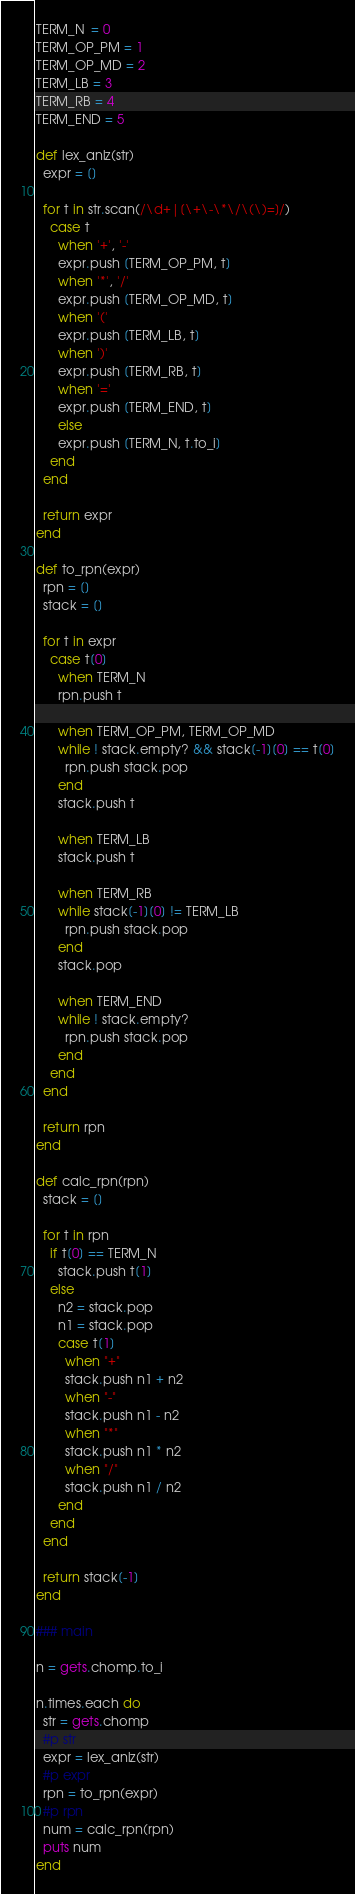<code> <loc_0><loc_0><loc_500><loc_500><_Ruby_>TERM_N  = 0
TERM_OP_PM = 1
TERM_OP_MD = 2
TERM_LB = 3
TERM_RB = 4
TERM_END = 5

def lex_anlz(str)
  expr = []

  for t in str.scan(/\d+|[\+\-\*\/\(\)=]/)
    case t
      when '+', '-'
      expr.push [TERM_OP_PM, t]
      when '*', '/'
      expr.push [TERM_OP_MD, t]
      when '('
      expr.push [TERM_LB, t]
      when ')'
      expr.push [TERM_RB, t]
      when '='
      expr.push [TERM_END, t]
      else
      expr.push [TERM_N, t.to_i]
    end
  end

  return expr
end

def to_rpn(expr)
  rpn = []
  stack = []

  for t in expr
    case t[0]
      when TERM_N
      rpn.push t

      when TERM_OP_PM, TERM_OP_MD
      while ! stack.empty? && stack[-1][0] == t[0]
        rpn.push stack.pop
      end
      stack.push t

      when TERM_LB
      stack.push t

      when TERM_RB
      while stack[-1][0] != TERM_LB
        rpn.push stack.pop
      end
      stack.pop

      when TERM_END
      while ! stack.empty?
        rpn.push stack.pop
      end
    end
  end

  return rpn
end

def calc_rpn(rpn)
  stack = []

  for t in rpn
    if t[0] == TERM_N
      stack.push t[1]
    else
      n2 = stack.pop
      n1 = stack.pop
      case t[1]
        when "+"
        stack.push n1 + n2
        when "-"
        stack.push n1 - n2
        when "*"
        stack.push n1 * n2
        when "/"
        stack.push n1 / n2
      end
    end
  end

  return stack[-1]
end

### main

n = gets.chomp.to_i

n.times.each do
  str = gets.chomp
  #p str
  expr = lex_anlz(str)
  #p expr
  rpn = to_rpn(expr)
  #p rpn
  num = calc_rpn(rpn)
  puts num
end</code> 